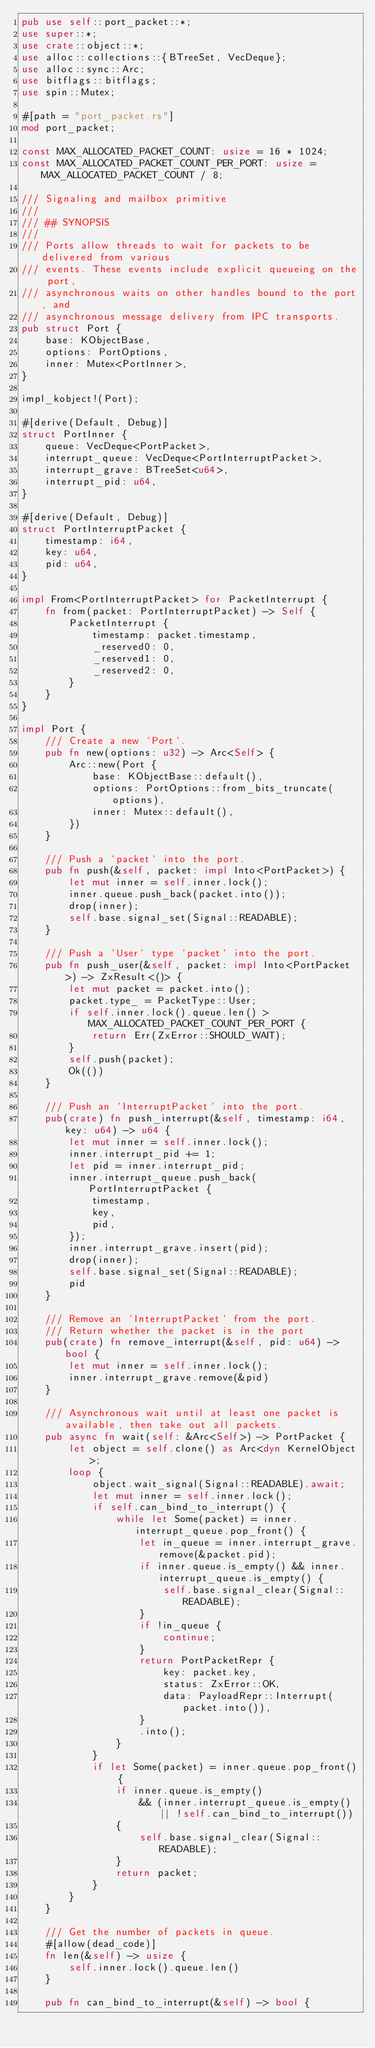<code> <loc_0><loc_0><loc_500><loc_500><_Rust_>pub use self::port_packet::*;
use super::*;
use crate::object::*;
use alloc::collections::{BTreeSet, VecDeque};
use alloc::sync::Arc;
use bitflags::bitflags;
use spin::Mutex;

#[path = "port_packet.rs"]
mod port_packet;

const MAX_ALLOCATED_PACKET_COUNT: usize = 16 * 1024;
const MAX_ALLOCATED_PACKET_COUNT_PER_PORT: usize = MAX_ALLOCATED_PACKET_COUNT / 8;

/// Signaling and mailbox primitive
///
/// ## SYNOPSIS
///
/// Ports allow threads to wait for packets to be delivered from various
/// events. These events include explicit queueing on the port,
/// asynchronous waits on other handles bound to the port, and
/// asynchronous message delivery from IPC transports.
pub struct Port {
    base: KObjectBase,
    options: PortOptions,
    inner: Mutex<PortInner>,
}

impl_kobject!(Port);

#[derive(Default, Debug)]
struct PortInner {
    queue: VecDeque<PortPacket>,
    interrupt_queue: VecDeque<PortInterruptPacket>,
    interrupt_grave: BTreeSet<u64>,
    interrupt_pid: u64,
}

#[derive(Default, Debug)]
struct PortInterruptPacket {
    timestamp: i64,
    key: u64,
    pid: u64,
}

impl From<PortInterruptPacket> for PacketInterrupt {
    fn from(packet: PortInterruptPacket) -> Self {
        PacketInterrupt {
            timestamp: packet.timestamp,
            _reserved0: 0,
            _reserved1: 0,
            _reserved2: 0,
        }
    }
}

impl Port {
    /// Create a new `Port`.
    pub fn new(options: u32) -> Arc<Self> {
        Arc::new(Port {
            base: KObjectBase::default(),
            options: PortOptions::from_bits_truncate(options),
            inner: Mutex::default(),
        })
    }

    /// Push a `packet` into the port.
    pub fn push(&self, packet: impl Into<PortPacket>) {
        let mut inner = self.inner.lock();
        inner.queue.push_back(packet.into());
        drop(inner);
        self.base.signal_set(Signal::READABLE);
    }

    /// Push a `User` type `packet` into the port.
    pub fn push_user(&self, packet: impl Into<PortPacket>) -> ZxResult<()> {
        let mut packet = packet.into();
        packet.type_ = PacketType::User;
        if self.inner.lock().queue.len() > MAX_ALLOCATED_PACKET_COUNT_PER_PORT {
            return Err(ZxError::SHOULD_WAIT);
        }
        self.push(packet);
        Ok(())
    }

    /// Push an `InterruptPacket` into the port.
    pub(crate) fn push_interrupt(&self, timestamp: i64, key: u64) -> u64 {
        let mut inner = self.inner.lock();
        inner.interrupt_pid += 1;
        let pid = inner.interrupt_pid;
        inner.interrupt_queue.push_back(PortInterruptPacket {
            timestamp,
            key,
            pid,
        });
        inner.interrupt_grave.insert(pid);
        drop(inner);
        self.base.signal_set(Signal::READABLE);
        pid
    }

    /// Remove an `InterruptPacket` from the port.
    /// Return whether the packet is in the port
    pub(crate) fn remove_interrupt(&self, pid: u64) -> bool {
        let mut inner = self.inner.lock();
        inner.interrupt_grave.remove(&pid)
    }

    /// Asynchronous wait until at least one packet is available, then take out all packets.
    pub async fn wait(self: &Arc<Self>) -> PortPacket {
        let object = self.clone() as Arc<dyn KernelObject>;
        loop {
            object.wait_signal(Signal::READABLE).await;
            let mut inner = self.inner.lock();
            if self.can_bind_to_interrupt() {
                while let Some(packet) = inner.interrupt_queue.pop_front() {
                    let in_queue = inner.interrupt_grave.remove(&packet.pid);
                    if inner.queue.is_empty() && inner.interrupt_queue.is_empty() {
                        self.base.signal_clear(Signal::READABLE);
                    }
                    if !in_queue {
                        continue;
                    }
                    return PortPacketRepr {
                        key: packet.key,
                        status: ZxError::OK,
                        data: PayloadRepr::Interrupt(packet.into()),
                    }
                    .into();
                }
            }
            if let Some(packet) = inner.queue.pop_front() {
                if inner.queue.is_empty()
                    && (inner.interrupt_queue.is_empty() || !self.can_bind_to_interrupt())
                {
                    self.base.signal_clear(Signal::READABLE);
                }
                return packet;
            }
        }
    }

    /// Get the number of packets in queue.
    #[allow(dead_code)]
    fn len(&self) -> usize {
        self.inner.lock().queue.len()
    }

    pub fn can_bind_to_interrupt(&self) -> bool {</code> 